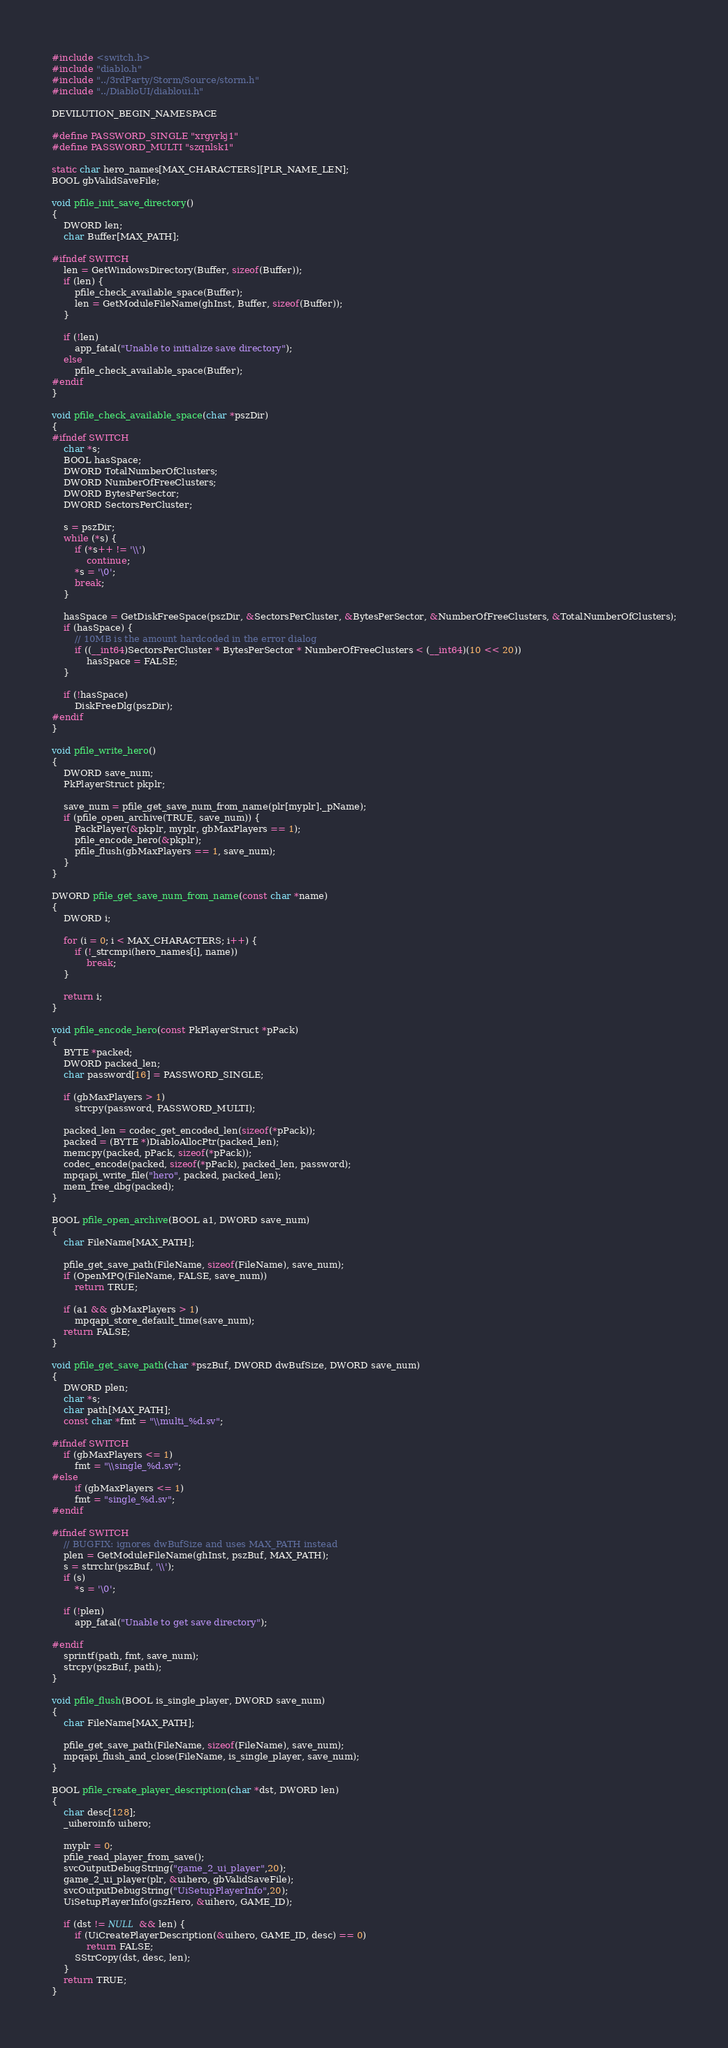<code> <loc_0><loc_0><loc_500><loc_500><_C++_>#include <switch.h>
#include "diablo.h"
#include "../3rdParty/Storm/Source/storm.h"
#include "../DiabloUI/diabloui.h"

DEVILUTION_BEGIN_NAMESPACE

#define PASSWORD_SINGLE "xrgyrkj1"
#define PASSWORD_MULTI "szqnlsk1"

static char hero_names[MAX_CHARACTERS][PLR_NAME_LEN];
BOOL gbValidSaveFile;

void pfile_init_save_directory()
{
	DWORD len;
	char Buffer[MAX_PATH];

#ifndef SWITCH	
	len = GetWindowsDirectory(Buffer, sizeof(Buffer));
	if (len) {
		pfile_check_available_space(Buffer);
		len = GetModuleFileName(ghInst, Buffer, sizeof(Buffer));
	}

	if (!len)
		app_fatal("Unable to initialize save directory");
	else
		pfile_check_available_space(Buffer);
#endif	
}

void pfile_check_available_space(char *pszDir)
{
#ifndef SWITCH		
	char *s;
	BOOL hasSpace;
	DWORD TotalNumberOfClusters;
	DWORD NumberOfFreeClusters;
	DWORD BytesPerSector;
	DWORD SectorsPerCluster;

	s = pszDir;
	while (*s) {
		if (*s++ != '\\')
			continue;
		*s = '\0';
		break;
	}

	hasSpace = GetDiskFreeSpace(pszDir, &SectorsPerCluster, &BytesPerSector, &NumberOfFreeClusters, &TotalNumberOfClusters);
	if (hasSpace) {
		// 10MB is the amount hardcoded in the error dialog
		if ((__int64)SectorsPerCluster * BytesPerSector * NumberOfFreeClusters < (__int64)(10 << 20))
			hasSpace = FALSE;
	}

	if (!hasSpace)
		DiskFreeDlg(pszDir);
#endif	
}

void pfile_write_hero()
{
	DWORD save_num;
	PkPlayerStruct pkplr;

	save_num = pfile_get_save_num_from_name(plr[myplr]._pName);
	if (pfile_open_archive(TRUE, save_num)) {
		PackPlayer(&pkplr, myplr, gbMaxPlayers == 1);
		pfile_encode_hero(&pkplr);
		pfile_flush(gbMaxPlayers == 1, save_num);
	}
}

DWORD pfile_get_save_num_from_name(const char *name)
{
	DWORD i;

	for (i = 0; i < MAX_CHARACTERS; i++) {
		if (!_strcmpi(hero_names[i], name))
			break;
	}

	return i;
}

void pfile_encode_hero(const PkPlayerStruct *pPack)
{
	BYTE *packed;
	DWORD packed_len;
	char password[16] = PASSWORD_SINGLE;

	if (gbMaxPlayers > 1)
		strcpy(password, PASSWORD_MULTI);

	packed_len = codec_get_encoded_len(sizeof(*pPack));
	packed = (BYTE *)DiabloAllocPtr(packed_len);
	memcpy(packed, pPack, sizeof(*pPack));
	codec_encode(packed, sizeof(*pPack), packed_len, password);
	mpqapi_write_file("hero", packed, packed_len);
	mem_free_dbg(packed);
}

BOOL pfile_open_archive(BOOL a1, DWORD save_num)
{
	char FileName[MAX_PATH];

	pfile_get_save_path(FileName, sizeof(FileName), save_num);
	if (OpenMPQ(FileName, FALSE, save_num))
		return TRUE;

	if (a1 && gbMaxPlayers > 1)
		mpqapi_store_default_time(save_num);
	return FALSE;
}

void pfile_get_save_path(char *pszBuf, DWORD dwBufSize, DWORD save_num)
{
	DWORD plen;
	char *s;
	char path[MAX_PATH];
	const char *fmt = "\\multi_%d.sv";

#ifndef SWITCH	
	if (gbMaxPlayers <= 1)
		fmt = "\\single_%d.sv";
#else
		if (gbMaxPlayers <= 1)
		fmt = "single_%d.sv";
#endif	

#ifndef SWITCH	
	// BUGFIX: ignores dwBufSize and uses MAX_PATH instead
	plen = GetModuleFileName(ghInst, pszBuf, MAX_PATH);
	s = strrchr(pszBuf, '\\');
	if (s)
		*s = '\0';

	if (!plen)
		app_fatal("Unable to get save directory");

#endif	
	sprintf(path, fmt, save_num);
	strcpy(pszBuf, path);
}

void pfile_flush(BOOL is_single_player, DWORD save_num)
{
	char FileName[MAX_PATH];

	pfile_get_save_path(FileName, sizeof(FileName), save_num);
	mpqapi_flush_and_close(FileName, is_single_player, save_num);
}

BOOL pfile_create_player_description(char *dst, DWORD len)
{
	char desc[128];
	_uiheroinfo uihero;

	myplr = 0;
	pfile_read_player_from_save();
	svcOutputDebugString("game_2_ui_player",20);
	game_2_ui_player(plr, &uihero, gbValidSaveFile);
	svcOutputDebugString("UiSetupPlayerInfo",20);
	UiSetupPlayerInfo(gszHero, &uihero, GAME_ID);

	if (dst != NULL && len) {
		if (UiCreatePlayerDescription(&uihero, GAME_ID, desc) == 0)
			return FALSE;
		SStrCopy(dst, desc, len);
	}
	return TRUE;
}
</code> 